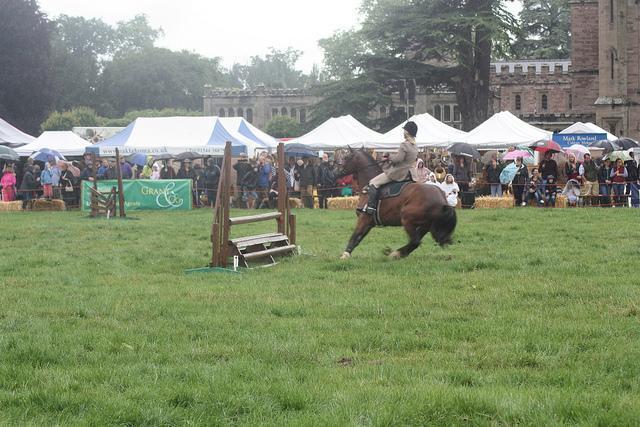How many horses are there?
Give a very brief answer. 1. How many umbrellas are there?
Give a very brief answer. 2. How many people are visible?
Give a very brief answer. 2. How many ski poles does the man have?
Give a very brief answer. 0. 